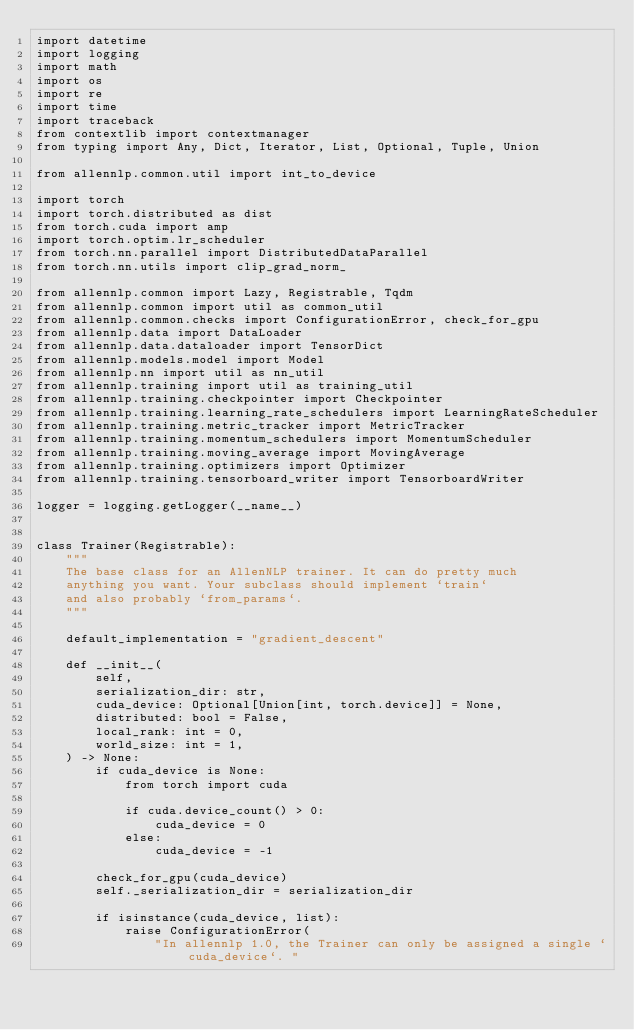Convert code to text. <code><loc_0><loc_0><loc_500><loc_500><_Python_>import datetime
import logging
import math
import os
import re
import time
import traceback
from contextlib import contextmanager
from typing import Any, Dict, Iterator, List, Optional, Tuple, Union

from allennlp.common.util import int_to_device

import torch
import torch.distributed as dist
from torch.cuda import amp
import torch.optim.lr_scheduler
from torch.nn.parallel import DistributedDataParallel
from torch.nn.utils import clip_grad_norm_

from allennlp.common import Lazy, Registrable, Tqdm
from allennlp.common import util as common_util
from allennlp.common.checks import ConfigurationError, check_for_gpu
from allennlp.data import DataLoader
from allennlp.data.dataloader import TensorDict
from allennlp.models.model import Model
from allennlp.nn import util as nn_util
from allennlp.training import util as training_util
from allennlp.training.checkpointer import Checkpointer
from allennlp.training.learning_rate_schedulers import LearningRateScheduler
from allennlp.training.metric_tracker import MetricTracker
from allennlp.training.momentum_schedulers import MomentumScheduler
from allennlp.training.moving_average import MovingAverage
from allennlp.training.optimizers import Optimizer
from allennlp.training.tensorboard_writer import TensorboardWriter

logger = logging.getLogger(__name__)


class Trainer(Registrable):
    """
    The base class for an AllenNLP trainer. It can do pretty much
    anything you want. Your subclass should implement `train`
    and also probably `from_params`.
    """

    default_implementation = "gradient_descent"

    def __init__(
        self,
        serialization_dir: str,
        cuda_device: Optional[Union[int, torch.device]] = None,
        distributed: bool = False,
        local_rank: int = 0,
        world_size: int = 1,
    ) -> None:
        if cuda_device is None:
            from torch import cuda

            if cuda.device_count() > 0:
                cuda_device = 0
            else:
                cuda_device = -1

        check_for_gpu(cuda_device)
        self._serialization_dir = serialization_dir

        if isinstance(cuda_device, list):
            raise ConfigurationError(
                "In allennlp 1.0, the Trainer can only be assigned a single `cuda_device`. "</code> 